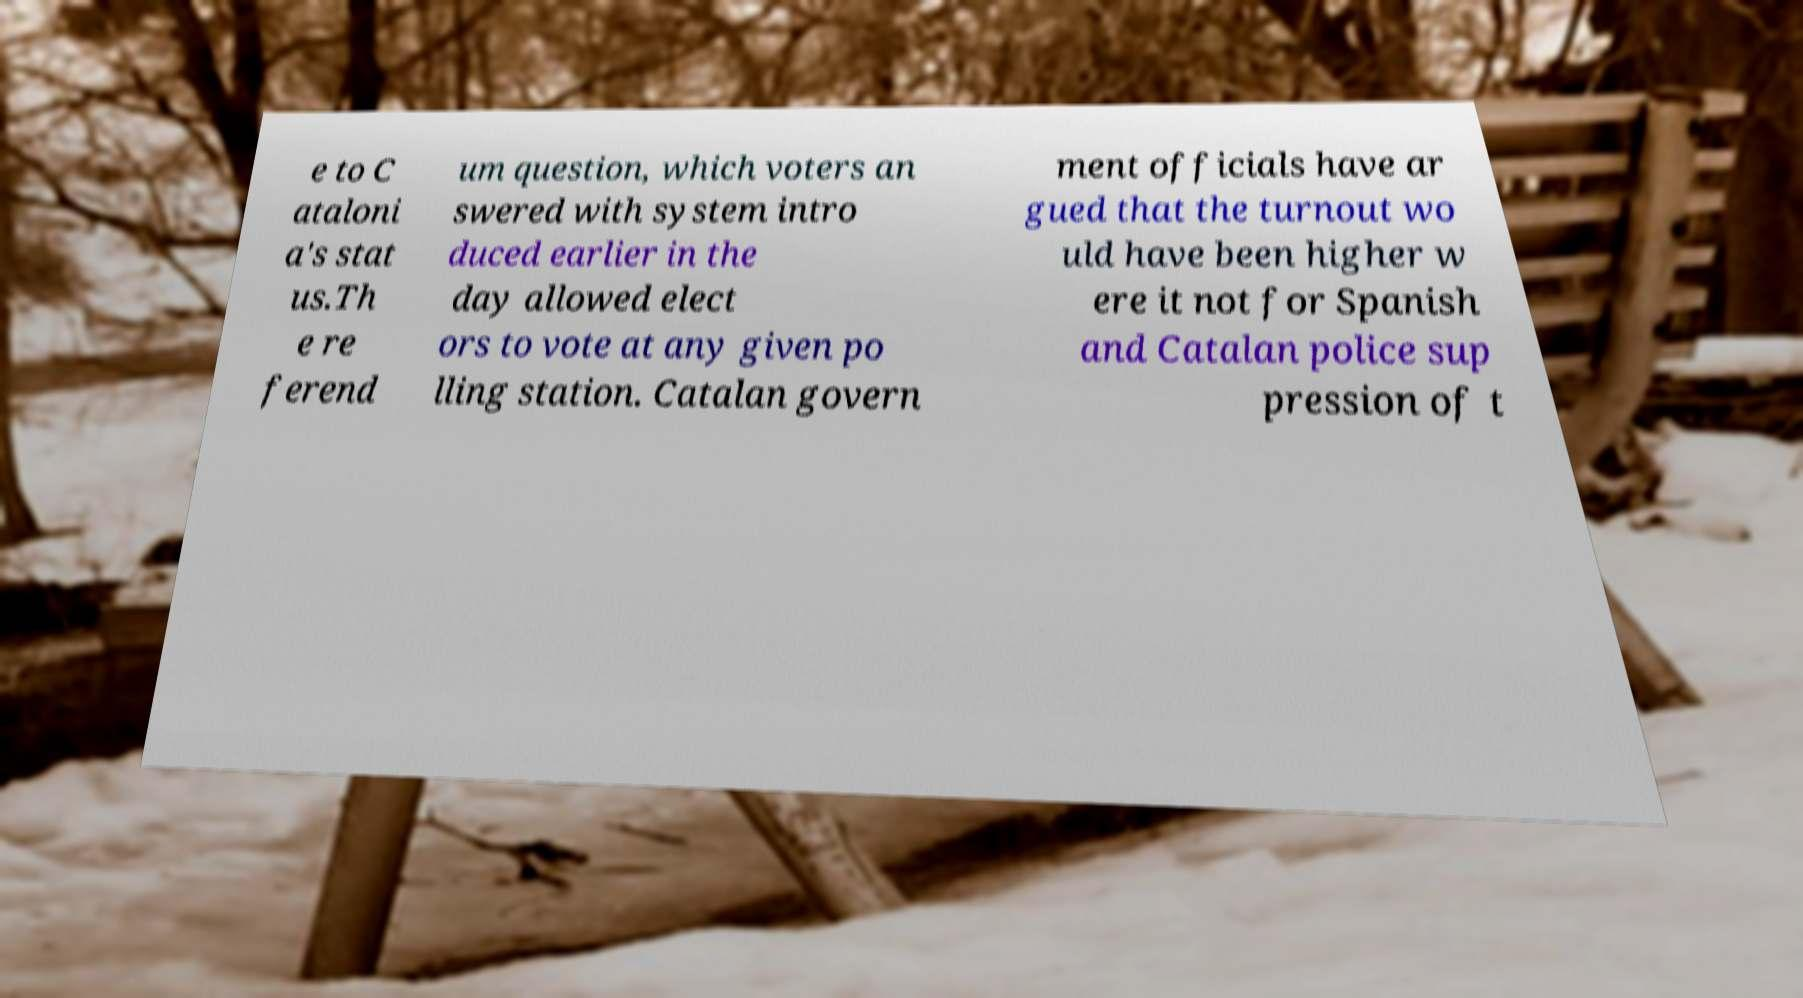Please identify and transcribe the text found in this image. e to C ataloni a's stat us.Th e re ferend um question, which voters an swered with system intro duced earlier in the day allowed elect ors to vote at any given po lling station. Catalan govern ment officials have ar gued that the turnout wo uld have been higher w ere it not for Spanish and Catalan police sup pression of t 